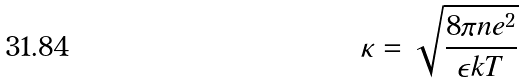<formula> <loc_0><loc_0><loc_500><loc_500>\kappa = \sqrt { \frac { 8 \pi n e ^ { 2 } } { \epsilon k T } }</formula> 